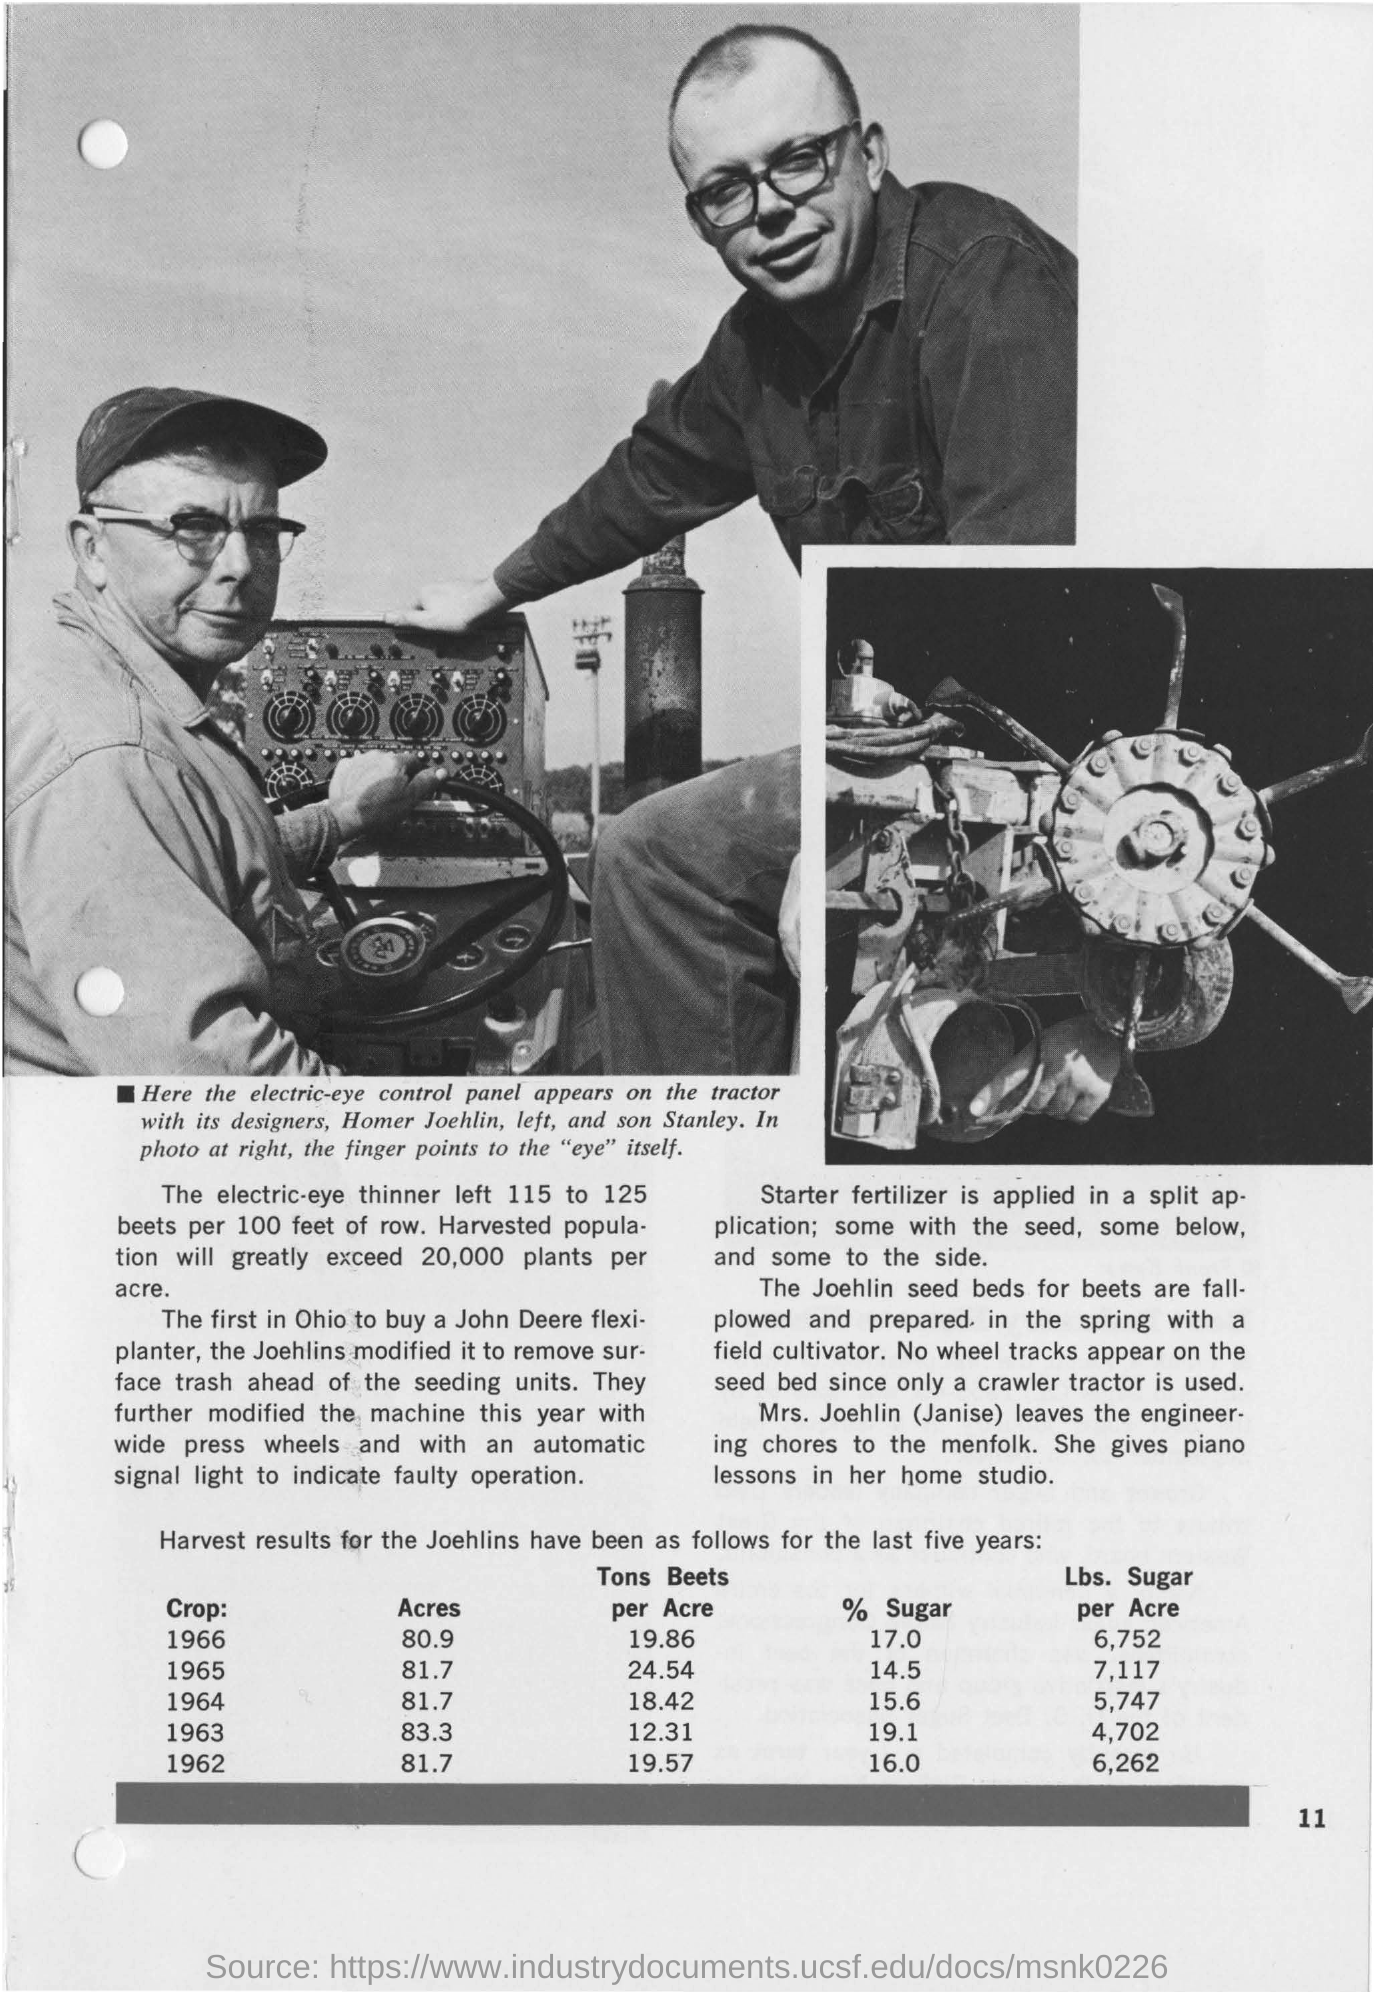Which year had the highest "acres" value?
Make the answer very short. 1963. Which year had the lowest "acres" value?
Your answer should be very brief. 1966. Which was the lowest % sugar value?
Keep it short and to the point. 14.5. Which was the highest "crop:" value?
Make the answer very short. 1966. 